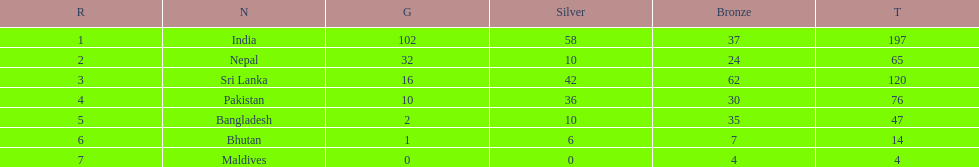Who has won the most bronze medals? Sri Lanka. 